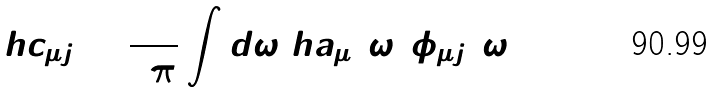<formula> <loc_0><loc_0><loc_500><loc_500>\ h c _ { \mu j } = \frac { 1 } { 2 \pi } \int d \omega \ h a _ { \mu } ( \omega ) \phi _ { \mu j } ( \omega )</formula> 